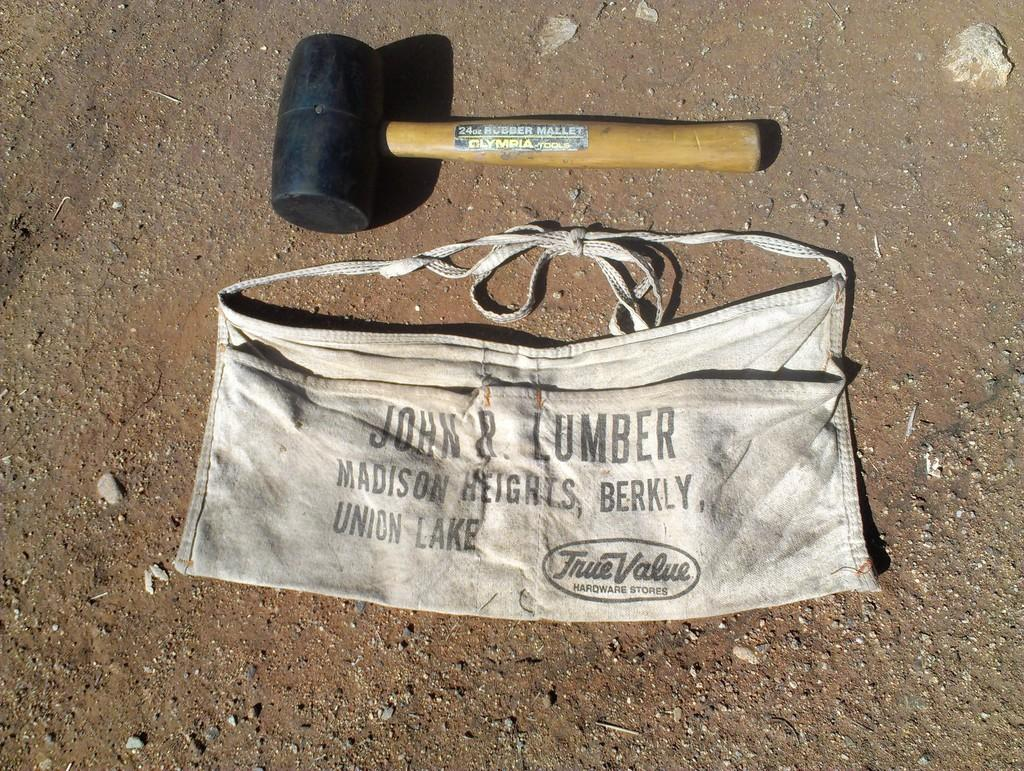What object can be seen in the image that might be used for carrying items? There is a bag in the image that might be used for carrying items. What object can be seen in the image that might be used for pounding or breaking? There is a hammer in the image that might be used for pounding or breaking. Where are the bag and hammer located in the image? Both the bag and the hammer are placed on a surface in the image. What type of bubble can be seen floating near the bag in the image? There is no bubble present in the image; it only features a bag and a hammer placed on a surface. 